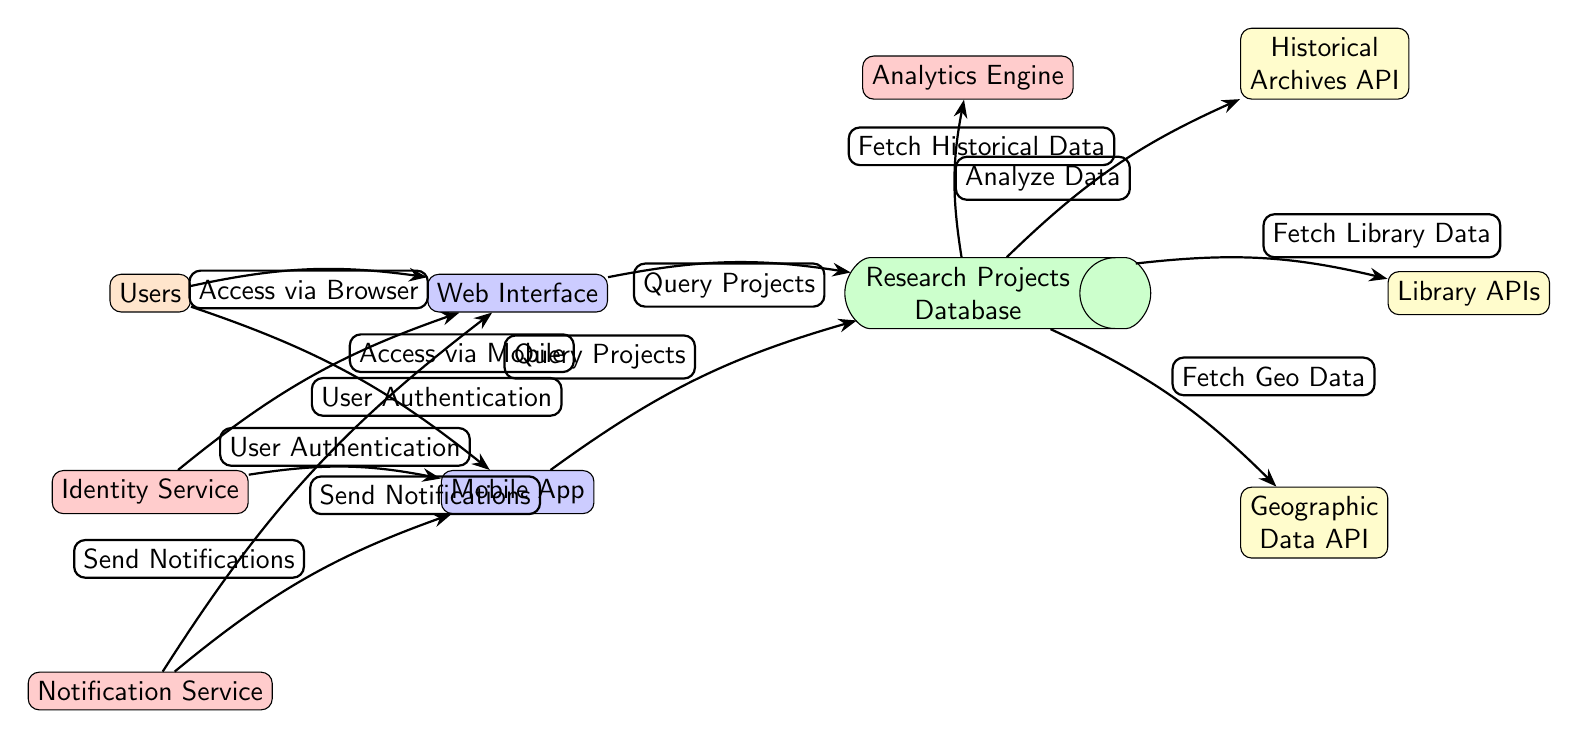What are the two user interfaces in the diagram? The diagram shows two user interfaces listed as nodes: 'Web Interface' and 'Mobile App.'
Answer: Web Interface and Mobile App How many APIs are connected to the Research Projects Database? In the diagram, there are three APIs connected to the 'Research Projects Database': 'Historical Archives API,' 'Library APIs,' and 'Geographic Data API.' Therefore, the total count is three.
Answer: Three What is the role of the Analytics Engine in the diagram? The 'Analytics Engine' receives the output from the 'Research Projects Database' that is analyzed, indicated by the edge labeled 'Analyze Data.' Thus, the role is to analyze data for insights or processing.
Answer: Analyze data Which service provides user authentication for both interfaces? The 'Identity Service' is connected to both the 'Web Interface' and 'Mobile App' for user authentication, as indicated by the edges labeled 'User Authentication.'
Answer: Identity Service What kind of data does the Geographic Data API fetch? The edge labeled 'Fetch Geo Data' connecting 'Research Projects Database' to 'Geographic Data API' indicates that the Geographic Data API fetches geographic data.
Answer: Geographic data What action does the Notification Service take, and for what purpose? The 'Notification Service' sends notifications through the 'Web Interface' and 'Mobile App' as shown with the edges labeled 'Send Notifications.' The purpose is to keep users informed.
Answer: Send notifications How are users accessing the platform? The 'Users' node connects to 'Web Interface' via 'Access via Browser' and to 'Mobile App' via 'Access via Mobile,' indicating that users can access the platform using both browser and mobile methods.
Answer: Browser and mobile What color represents the database node in the diagram? The 'Research Projects Database' is represented in green, as indicated by the fill color style in the diagram.
Answer: Green 